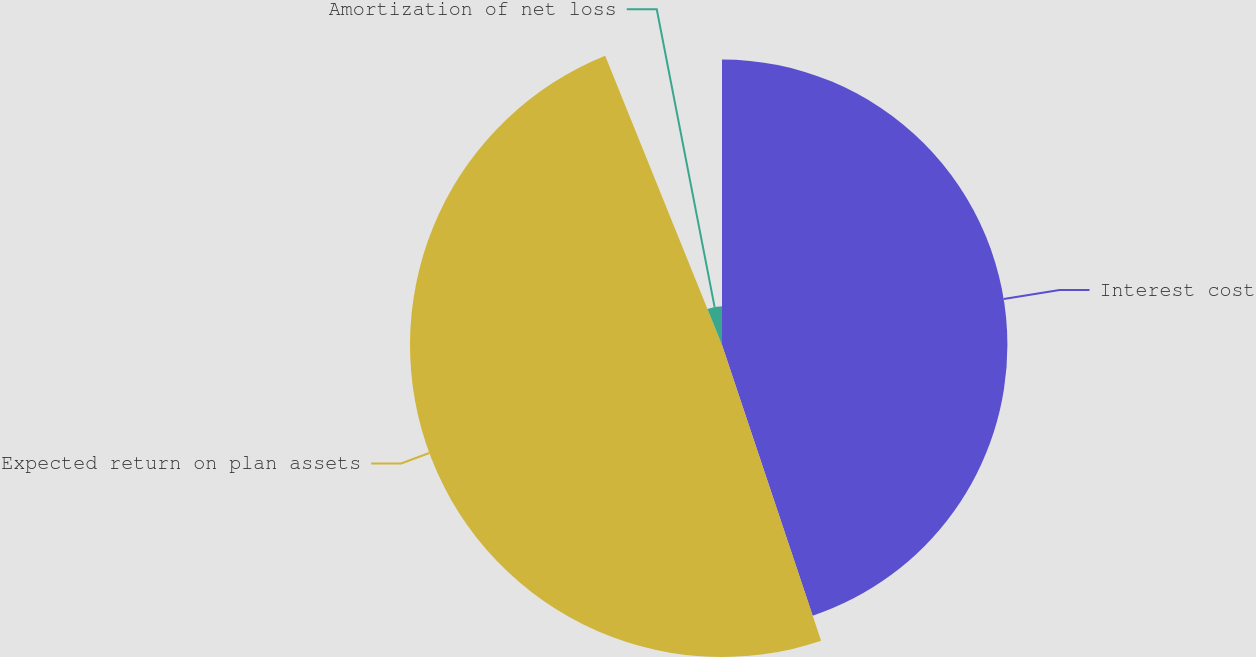Convert chart to OTSL. <chart><loc_0><loc_0><loc_500><loc_500><pie_chart><fcel>Interest cost<fcel>Expected return on plan assets<fcel>Amortization of net loss<nl><fcel>44.86%<fcel>49.04%<fcel>6.11%<nl></chart> 